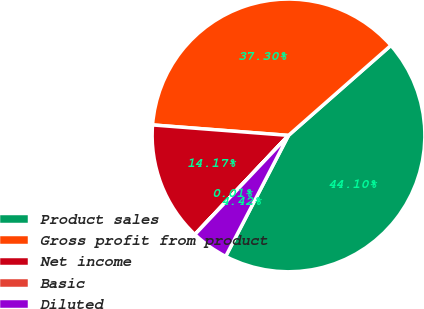Convert chart to OTSL. <chart><loc_0><loc_0><loc_500><loc_500><pie_chart><fcel>Product sales<fcel>Gross profit from product<fcel>Net income<fcel>Basic<fcel>Diluted<nl><fcel>44.1%<fcel>37.3%<fcel>14.17%<fcel>0.01%<fcel>4.42%<nl></chart> 